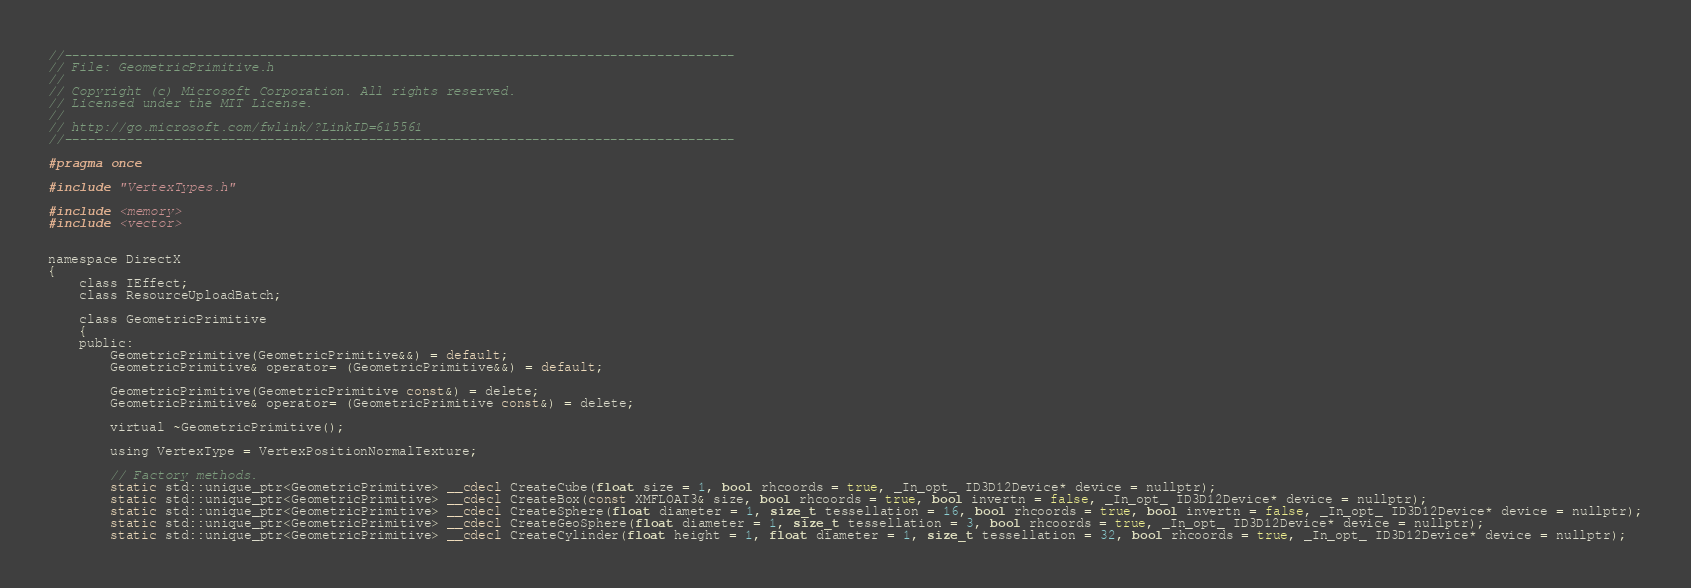Convert code to text. <code><loc_0><loc_0><loc_500><loc_500><_C_>//--------------------------------------------------------------------------------------
// File: GeometricPrimitive.h
//
// Copyright (c) Microsoft Corporation. All rights reserved.
// Licensed under the MIT License.
//
// http://go.microsoft.com/fwlink/?LinkID=615561
//--------------------------------------------------------------------------------------

#pragma once

#include "VertexTypes.h"

#include <memory>
#include <vector>


namespace DirectX
{
    class IEffect;
    class ResourceUploadBatch;

    class GeometricPrimitive
    {
    public:
        GeometricPrimitive(GeometricPrimitive&&) = default;
        GeometricPrimitive& operator= (GeometricPrimitive&&) = default;

        GeometricPrimitive(GeometricPrimitive const&) = delete;
        GeometricPrimitive& operator= (GeometricPrimitive const&) = delete;

        virtual ~GeometricPrimitive();

        using VertexType = VertexPositionNormalTexture;

        // Factory methods.
        static std::unique_ptr<GeometricPrimitive> __cdecl CreateCube(float size = 1, bool rhcoords = true, _In_opt_ ID3D12Device* device = nullptr);
        static std::unique_ptr<GeometricPrimitive> __cdecl CreateBox(const XMFLOAT3& size, bool rhcoords = true, bool invertn = false, _In_opt_ ID3D12Device* device = nullptr);
        static std::unique_ptr<GeometricPrimitive> __cdecl CreateSphere(float diameter = 1, size_t tessellation = 16, bool rhcoords = true, bool invertn = false, _In_opt_ ID3D12Device* device = nullptr);
        static std::unique_ptr<GeometricPrimitive> __cdecl CreateGeoSphere(float diameter = 1, size_t tessellation = 3, bool rhcoords = true, _In_opt_ ID3D12Device* device = nullptr);
        static std::unique_ptr<GeometricPrimitive> __cdecl CreateCylinder(float height = 1, float diameter = 1, size_t tessellation = 32, bool rhcoords = true, _In_opt_ ID3D12Device* device = nullptr);</code> 